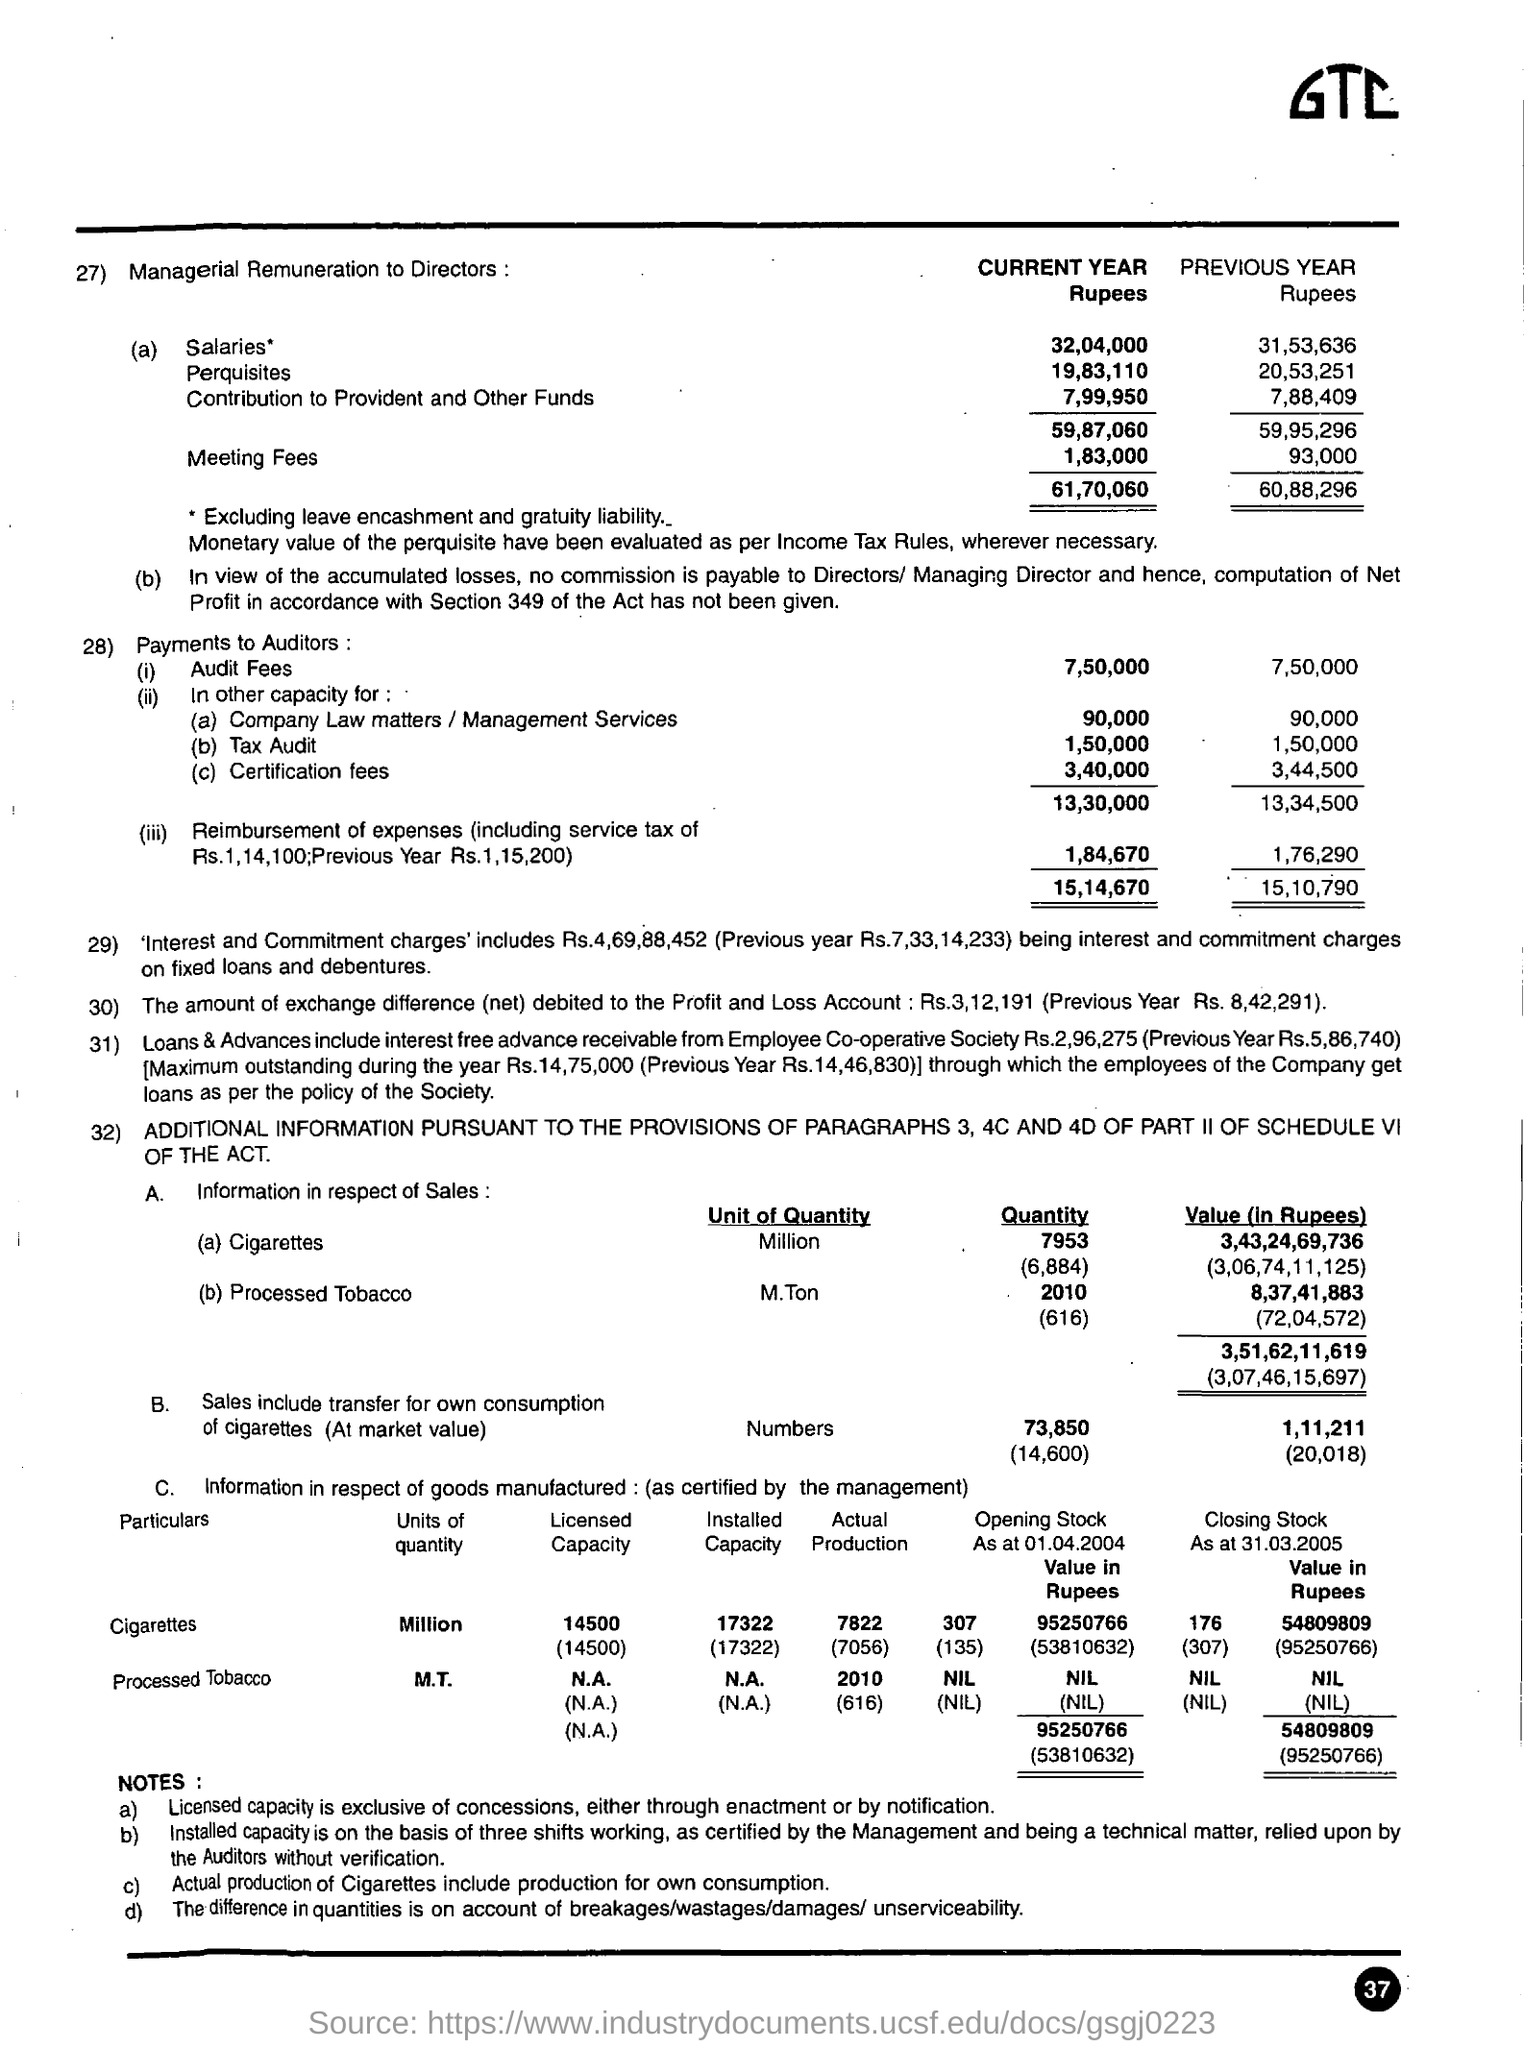Highlight a few significant elements in this photo. The previous year, a total of 7,50,000 rupees was paid as audit fees. The value of cigarettes and processed tobacco is measured in rupees. The licensed capacity of cigarettes is 14,500 million. The audit fees for the current year amounted to 7,50,000 rupees. The certification fees paid to the auditors in the current year were 3,40,000. 